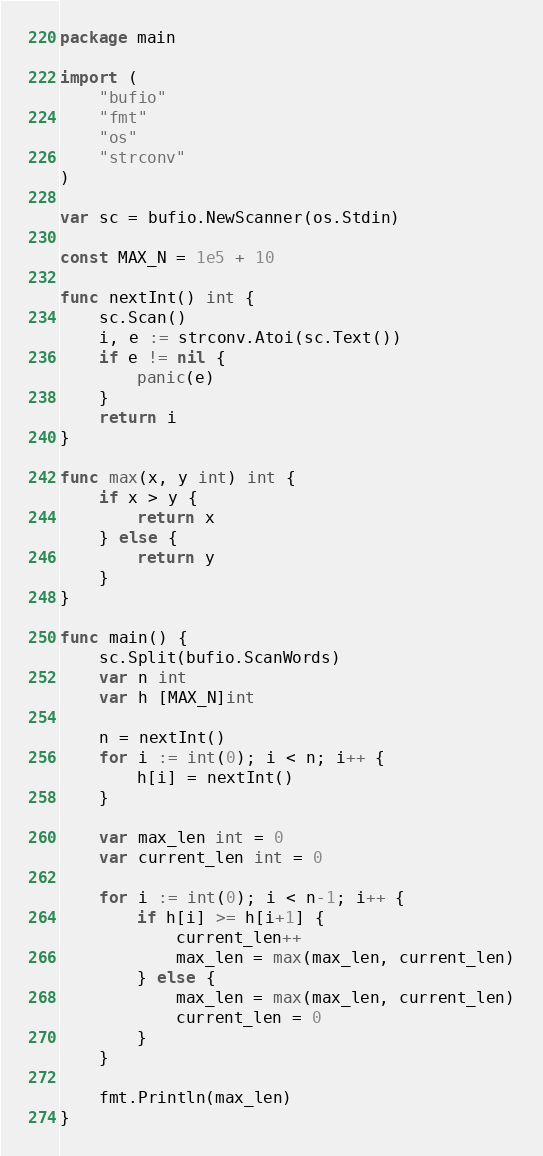<code> <loc_0><loc_0><loc_500><loc_500><_Go_>package main

import (
    "bufio"
    "fmt"
    "os"
    "strconv"
)

var sc = bufio.NewScanner(os.Stdin)

const MAX_N = 1e5 + 10

func nextInt() int {
    sc.Scan()
    i, e := strconv.Atoi(sc.Text())
    if e != nil {
        panic(e)
    }
    return i
}

func max(x, y int) int {
	if x > y {
		return x
	} else {
		return y
	}
}

func main() {
	sc.Split(bufio.ScanWords)
	var n int
	var h [MAX_N]int

	n = nextInt()
	for i := int(0); i < n; i++ {
		h[i] = nextInt()
	}

	var max_len int = 0
	var current_len int = 0

	for i := int(0); i < n-1; i++ {
		if h[i] >= h[i+1] {
			current_len++
			max_len = max(max_len, current_len)
		} else {
			max_len = max(max_len, current_len)
			current_len = 0
		}
	}

	fmt.Println(max_len)
}</code> 